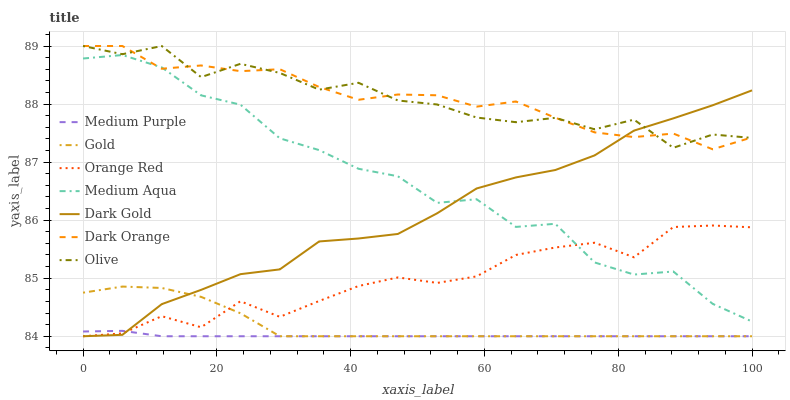Does Medium Purple have the minimum area under the curve?
Answer yes or no. Yes. Does Dark Orange have the maximum area under the curve?
Answer yes or no. Yes. Does Gold have the minimum area under the curve?
Answer yes or no. No. Does Gold have the maximum area under the curve?
Answer yes or no. No. Is Medium Purple the smoothest?
Answer yes or no. Yes. Is Medium Aqua the roughest?
Answer yes or no. Yes. Is Gold the smoothest?
Answer yes or no. No. Is Gold the roughest?
Answer yes or no. No. Does Medium Aqua have the lowest value?
Answer yes or no. No. Does Olive have the highest value?
Answer yes or no. Yes. Does Gold have the highest value?
Answer yes or no. No. Is Medium Purple less than Dark Orange?
Answer yes or no. Yes. Is Olive greater than Medium Aqua?
Answer yes or no. Yes. Does Medium Purple intersect Orange Red?
Answer yes or no. Yes. Is Medium Purple less than Orange Red?
Answer yes or no. No. Is Medium Purple greater than Orange Red?
Answer yes or no. No. Does Medium Purple intersect Dark Orange?
Answer yes or no. No. 